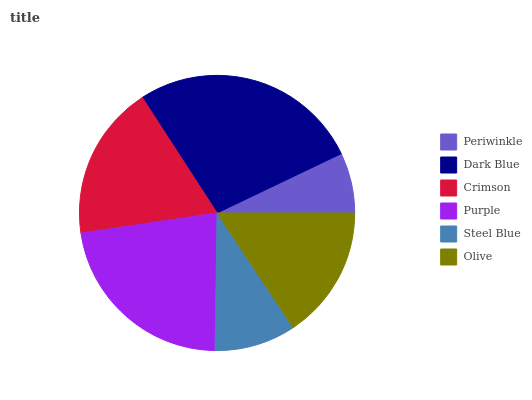Is Periwinkle the minimum?
Answer yes or no. Yes. Is Dark Blue the maximum?
Answer yes or no. Yes. Is Crimson the minimum?
Answer yes or no. No. Is Crimson the maximum?
Answer yes or no. No. Is Dark Blue greater than Crimson?
Answer yes or no. Yes. Is Crimson less than Dark Blue?
Answer yes or no. Yes. Is Crimson greater than Dark Blue?
Answer yes or no. No. Is Dark Blue less than Crimson?
Answer yes or no. No. Is Crimson the high median?
Answer yes or no. Yes. Is Olive the low median?
Answer yes or no. Yes. Is Steel Blue the high median?
Answer yes or no. No. Is Crimson the low median?
Answer yes or no. No. 